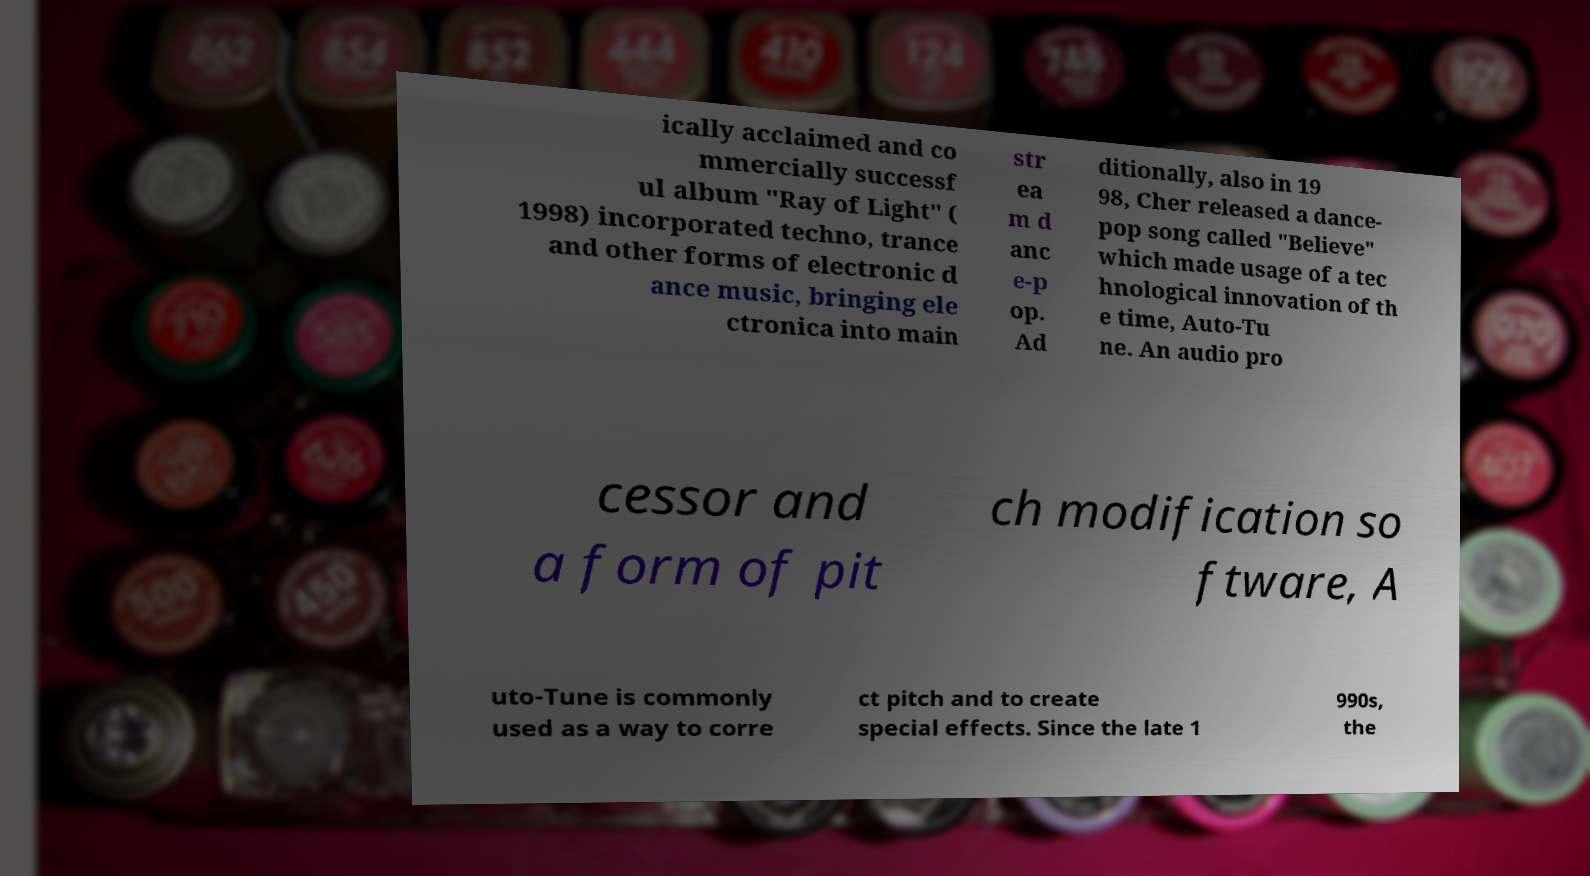Could you extract and type out the text from this image? ically acclaimed and co mmercially successf ul album "Ray of Light" ( 1998) incorporated techno, trance and other forms of electronic d ance music, bringing ele ctronica into main str ea m d anc e-p op. Ad ditionally, also in 19 98, Cher released a dance- pop song called "Believe" which made usage of a tec hnological innovation of th e time, Auto-Tu ne. An audio pro cessor and a form of pit ch modification so ftware, A uto-Tune is commonly used as a way to corre ct pitch and to create special effects. Since the late 1 990s, the 